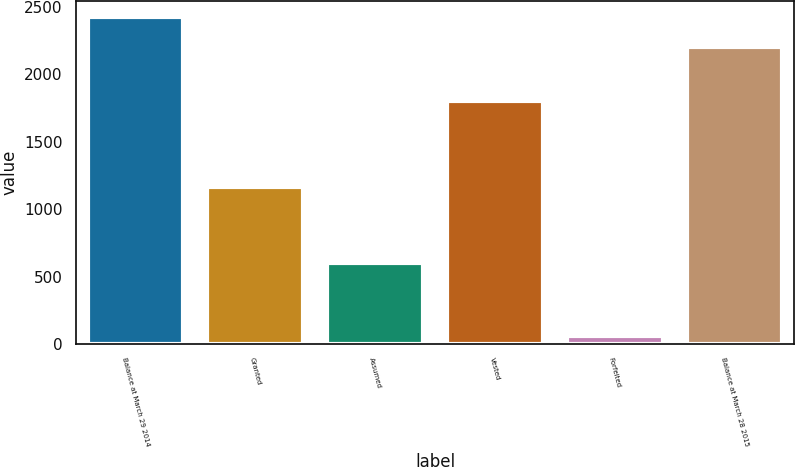<chart> <loc_0><loc_0><loc_500><loc_500><bar_chart><fcel>Balance at March 29 2014<fcel>Granted<fcel>Assumed<fcel>Vested<fcel>Forfeited<fcel>Balance at March 28 2015<nl><fcel>2426.3<fcel>1166<fcel>599<fcel>1806<fcel>55<fcel>2202<nl></chart> 